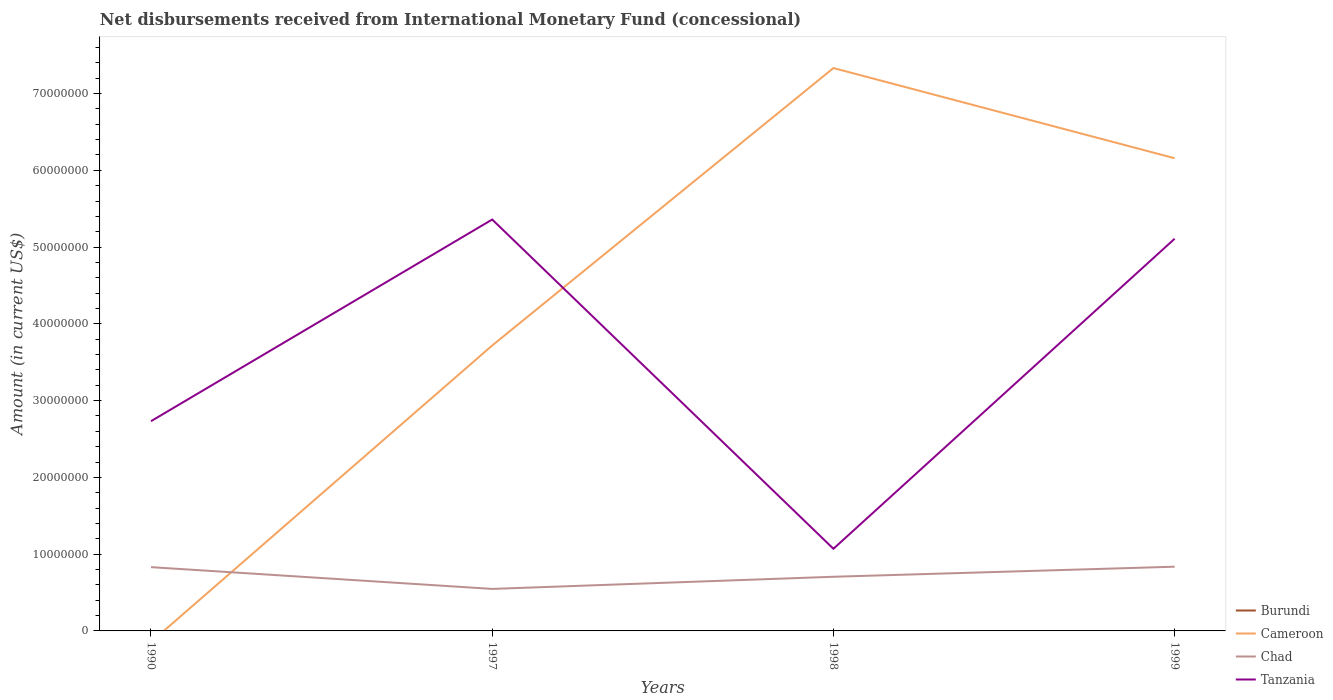How many different coloured lines are there?
Your answer should be compact. 3. Across all years, what is the maximum amount of disbursements received from International Monetary Fund in Burundi?
Offer a terse response. 0. What is the total amount of disbursements received from International Monetary Fund in Chad in the graph?
Your response must be concise. -1.58e+06. What is the difference between the highest and the second highest amount of disbursements received from International Monetary Fund in Tanzania?
Provide a short and direct response. 4.29e+07. How many lines are there?
Provide a short and direct response. 3. What is the difference between two consecutive major ticks on the Y-axis?
Ensure brevity in your answer.  1.00e+07. Are the values on the major ticks of Y-axis written in scientific E-notation?
Offer a terse response. No. Does the graph contain any zero values?
Offer a terse response. Yes. How many legend labels are there?
Offer a very short reply. 4. How are the legend labels stacked?
Your answer should be compact. Vertical. What is the title of the graph?
Make the answer very short. Net disbursements received from International Monetary Fund (concessional). Does "Papua New Guinea" appear as one of the legend labels in the graph?
Offer a terse response. No. What is the label or title of the X-axis?
Offer a very short reply. Years. What is the Amount (in current US$) of Cameroon in 1990?
Your answer should be very brief. 0. What is the Amount (in current US$) of Chad in 1990?
Offer a very short reply. 8.31e+06. What is the Amount (in current US$) of Tanzania in 1990?
Ensure brevity in your answer.  2.73e+07. What is the Amount (in current US$) in Cameroon in 1997?
Your answer should be compact. 3.72e+07. What is the Amount (in current US$) of Chad in 1997?
Your answer should be very brief. 5.47e+06. What is the Amount (in current US$) in Tanzania in 1997?
Give a very brief answer. 5.36e+07. What is the Amount (in current US$) in Cameroon in 1998?
Keep it short and to the point. 7.33e+07. What is the Amount (in current US$) in Chad in 1998?
Offer a very short reply. 7.06e+06. What is the Amount (in current US$) of Tanzania in 1998?
Ensure brevity in your answer.  1.07e+07. What is the Amount (in current US$) of Cameroon in 1999?
Give a very brief answer. 6.16e+07. What is the Amount (in current US$) in Chad in 1999?
Provide a succinct answer. 8.37e+06. What is the Amount (in current US$) of Tanzania in 1999?
Your answer should be compact. 5.11e+07. Across all years, what is the maximum Amount (in current US$) of Cameroon?
Your answer should be compact. 7.33e+07. Across all years, what is the maximum Amount (in current US$) in Chad?
Offer a terse response. 8.37e+06. Across all years, what is the maximum Amount (in current US$) of Tanzania?
Your answer should be very brief. 5.36e+07. Across all years, what is the minimum Amount (in current US$) of Chad?
Provide a short and direct response. 5.47e+06. Across all years, what is the minimum Amount (in current US$) of Tanzania?
Keep it short and to the point. 1.07e+07. What is the total Amount (in current US$) in Cameroon in the graph?
Make the answer very short. 1.72e+08. What is the total Amount (in current US$) in Chad in the graph?
Offer a very short reply. 2.92e+07. What is the total Amount (in current US$) of Tanzania in the graph?
Your response must be concise. 1.43e+08. What is the difference between the Amount (in current US$) of Chad in 1990 and that in 1997?
Offer a very short reply. 2.84e+06. What is the difference between the Amount (in current US$) of Tanzania in 1990 and that in 1997?
Make the answer very short. -2.63e+07. What is the difference between the Amount (in current US$) in Chad in 1990 and that in 1998?
Keep it short and to the point. 1.25e+06. What is the difference between the Amount (in current US$) of Tanzania in 1990 and that in 1998?
Give a very brief answer. 1.66e+07. What is the difference between the Amount (in current US$) in Chad in 1990 and that in 1999?
Provide a succinct answer. -5.70e+04. What is the difference between the Amount (in current US$) in Tanzania in 1990 and that in 1999?
Your response must be concise. -2.38e+07. What is the difference between the Amount (in current US$) of Cameroon in 1997 and that in 1998?
Keep it short and to the point. -3.61e+07. What is the difference between the Amount (in current US$) of Chad in 1997 and that in 1998?
Provide a short and direct response. -1.58e+06. What is the difference between the Amount (in current US$) of Tanzania in 1997 and that in 1998?
Your answer should be very brief. 4.29e+07. What is the difference between the Amount (in current US$) in Cameroon in 1997 and that in 1999?
Your response must be concise. -2.44e+07. What is the difference between the Amount (in current US$) in Chad in 1997 and that in 1999?
Offer a very short reply. -2.89e+06. What is the difference between the Amount (in current US$) in Tanzania in 1997 and that in 1999?
Make the answer very short. 2.51e+06. What is the difference between the Amount (in current US$) in Cameroon in 1998 and that in 1999?
Make the answer very short. 1.17e+07. What is the difference between the Amount (in current US$) of Chad in 1998 and that in 1999?
Ensure brevity in your answer.  -1.31e+06. What is the difference between the Amount (in current US$) in Tanzania in 1998 and that in 1999?
Keep it short and to the point. -4.04e+07. What is the difference between the Amount (in current US$) in Chad in 1990 and the Amount (in current US$) in Tanzania in 1997?
Your response must be concise. -4.53e+07. What is the difference between the Amount (in current US$) of Chad in 1990 and the Amount (in current US$) of Tanzania in 1998?
Make the answer very short. -2.39e+06. What is the difference between the Amount (in current US$) of Chad in 1990 and the Amount (in current US$) of Tanzania in 1999?
Provide a short and direct response. -4.28e+07. What is the difference between the Amount (in current US$) of Cameroon in 1997 and the Amount (in current US$) of Chad in 1998?
Keep it short and to the point. 3.01e+07. What is the difference between the Amount (in current US$) of Cameroon in 1997 and the Amount (in current US$) of Tanzania in 1998?
Give a very brief answer. 2.65e+07. What is the difference between the Amount (in current US$) in Chad in 1997 and the Amount (in current US$) in Tanzania in 1998?
Your response must be concise. -5.23e+06. What is the difference between the Amount (in current US$) of Cameroon in 1997 and the Amount (in current US$) of Chad in 1999?
Your response must be concise. 2.88e+07. What is the difference between the Amount (in current US$) in Cameroon in 1997 and the Amount (in current US$) in Tanzania in 1999?
Make the answer very short. -1.39e+07. What is the difference between the Amount (in current US$) of Chad in 1997 and the Amount (in current US$) of Tanzania in 1999?
Ensure brevity in your answer.  -4.56e+07. What is the difference between the Amount (in current US$) in Cameroon in 1998 and the Amount (in current US$) in Chad in 1999?
Offer a terse response. 6.50e+07. What is the difference between the Amount (in current US$) of Cameroon in 1998 and the Amount (in current US$) of Tanzania in 1999?
Offer a terse response. 2.22e+07. What is the difference between the Amount (in current US$) of Chad in 1998 and the Amount (in current US$) of Tanzania in 1999?
Keep it short and to the point. -4.40e+07. What is the average Amount (in current US$) of Burundi per year?
Give a very brief answer. 0. What is the average Amount (in current US$) of Cameroon per year?
Make the answer very short. 4.30e+07. What is the average Amount (in current US$) of Chad per year?
Your answer should be compact. 7.30e+06. What is the average Amount (in current US$) of Tanzania per year?
Give a very brief answer. 3.57e+07. In the year 1990, what is the difference between the Amount (in current US$) in Chad and Amount (in current US$) in Tanzania?
Offer a terse response. -1.90e+07. In the year 1997, what is the difference between the Amount (in current US$) of Cameroon and Amount (in current US$) of Chad?
Make the answer very short. 3.17e+07. In the year 1997, what is the difference between the Amount (in current US$) of Cameroon and Amount (in current US$) of Tanzania?
Your answer should be compact. -1.64e+07. In the year 1997, what is the difference between the Amount (in current US$) in Chad and Amount (in current US$) in Tanzania?
Give a very brief answer. -4.81e+07. In the year 1998, what is the difference between the Amount (in current US$) of Cameroon and Amount (in current US$) of Chad?
Keep it short and to the point. 6.63e+07. In the year 1998, what is the difference between the Amount (in current US$) of Cameroon and Amount (in current US$) of Tanzania?
Make the answer very short. 6.26e+07. In the year 1998, what is the difference between the Amount (in current US$) of Chad and Amount (in current US$) of Tanzania?
Keep it short and to the point. -3.65e+06. In the year 1999, what is the difference between the Amount (in current US$) in Cameroon and Amount (in current US$) in Chad?
Keep it short and to the point. 5.32e+07. In the year 1999, what is the difference between the Amount (in current US$) in Cameroon and Amount (in current US$) in Tanzania?
Offer a terse response. 1.05e+07. In the year 1999, what is the difference between the Amount (in current US$) in Chad and Amount (in current US$) in Tanzania?
Your answer should be compact. -4.27e+07. What is the ratio of the Amount (in current US$) in Chad in 1990 to that in 1997?
Your response must be concise. 1.52. What is the ratio of the Amount (in current US$) of Tanzania in 1990 to that in 1997?
Provide a succinct answer. 0.51. What is the ratio of the Amount (in current US$) in Chad in 1990 to that in 1998?
Keep it short and to the point. 1.18. What is the ratio of the Amount (in current US$) in Tanzania in 1990 to that in 1998?
Keep it short and to the point. 2.55. What is the ratio of the Amount (in current US$) of Chad in 1990 to that in 1999?
Give a very brief answer. 0.99. What is the ratio of the Amount (in current US$) in Tanzania in 1990 to that in 1999?
Your answer should be very brief. 0.53. What is the ratio of the Amount (in current US$) in Cameroon in 1997 to that in 1998?
Provide a short and direct response. 0.51. What is the ratio of the Amount (in current US$) in Chad in 1997 to that in 1998?
Offer a terse response. 0.78. What is the ratio of the Amount (in current US$) of Tanzania in 1997 to that in 1998?
Provide a short and direct response. 5.01. What is the ratio of the Amount (in current US$) of Cameroon in 1997 to that in 1999?
Make the answer very short. 0.6. What is the ratio of the Amount (in current US$) of Chad in 1997 to that in 1999?
Give a very brief answer. 0.65. What is the ratio of the Amount (in current US$) in Tanzania in 1997 to that in 1999?
Make the answer very short. 1.05. What is the ratio of the Amount (in current US$) in Cameroon in 1998 to that in 1999?
Your answer should be compact. 1.19. What is the ratio of the Amount (in current US$) of Chad in 1998 to that in 1999?
Make the answer very short. 0.84. What is the ratio of the Amount (in current US$) of Tanzania in 1998 to that in 1999?
Offer a very short reply. 0.21. What is the difference between the highest and the second highest Amount (in current US$) in Cameroon?
Keep it short and to the point. 1.17e+07. What is the difference between the highest and the second highest Amount (in current US$) in Chad?
Provide a short and direct response. 5.70e+04. What is the difference between the highest and the second highest Amount (in current US$) of Tanzania?
Your answer should be compact. 2.51e+06. What is the difference between the highest and the lowest Amount (in current US$) in Cameroon?
Your response must be concise. 7.33e+07. What is the difference between the highest and the lowest Amount (in current US$) of Chad?
Offer a very short reply. 2.89e+06. What is the difference between the highest and the lowest Amount (in current US$) in Tanzania?
Your response must be concise. 4.29e+07. 